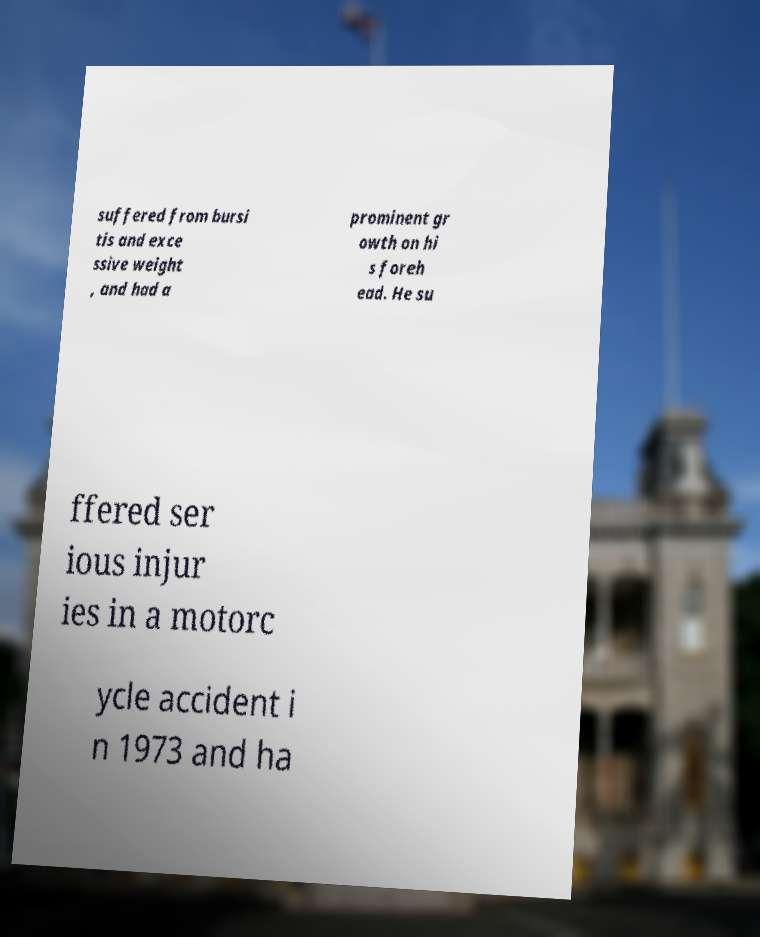For documentation purposes, I need the text within this image transcribed. Could you provide that? suffered from bursi tis and exce ssive weight , and had a prominent gr owth on hi s foreh ead. He su ffered ser ious injur ies in a motorc ycle accident i n 1973 and ha 